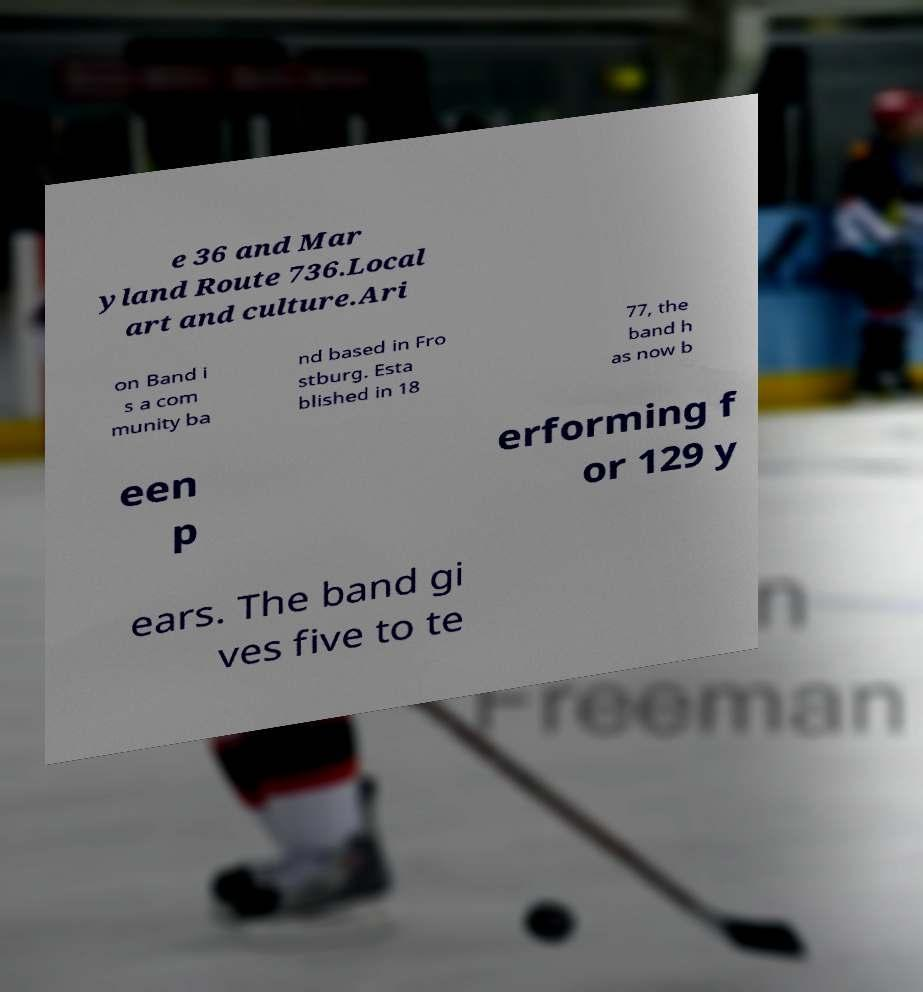For documentation purposes, I need the text within this image transcribed. Could you provide that? e 36 and Mar yland Route 736.Local art and culture.Ari on Band i s a com munity ba nd based in Fro stburg. Esta blished in 18 77, the band h as now b een p erforming f or 129 y ears. The band gi ves five to te 